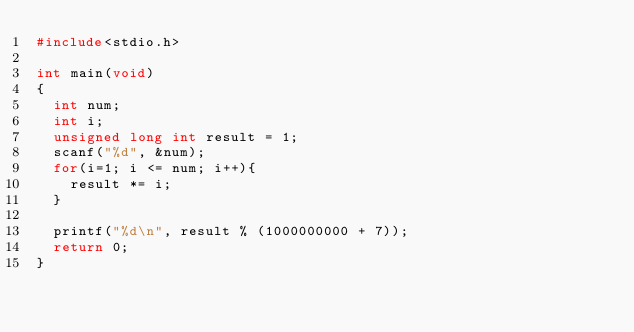<code> <loc_0><loc_0><loc_500><loc_500><_C_>#include<stdio.h>

int main(void)
{
	int num;
	int i;
	unsigned long int result = 1;
	scanf("%d", &num);
	for(i=1; i <= num; i++){
		result *= i;
	}

	printf("%d\n", result % (1000000000 + 7));
	return 0;
}
</code> 